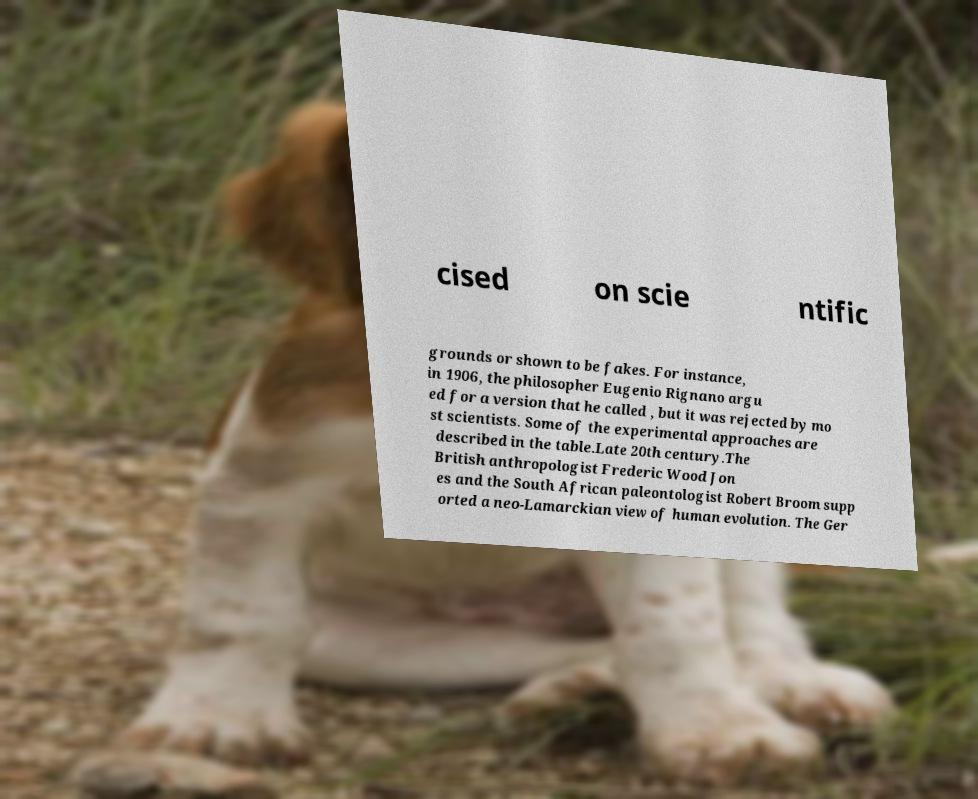What messages or text are displayed in this image? I need them in a readable, typed format. cised on scie ntific grounds or shown to be fakes. For instance, in 1906, the philosopher Eugenio Rignano argu ed for a version that he called , but it was rejected by mo st scientists. Some of the experimental approaches are described in the table.Late 20th century.The British anthropologist Frederic Wood Jon es and the South African paleontologist Robert Broom supp orted a neo-Lamarckian view of human evolution. The Ger 